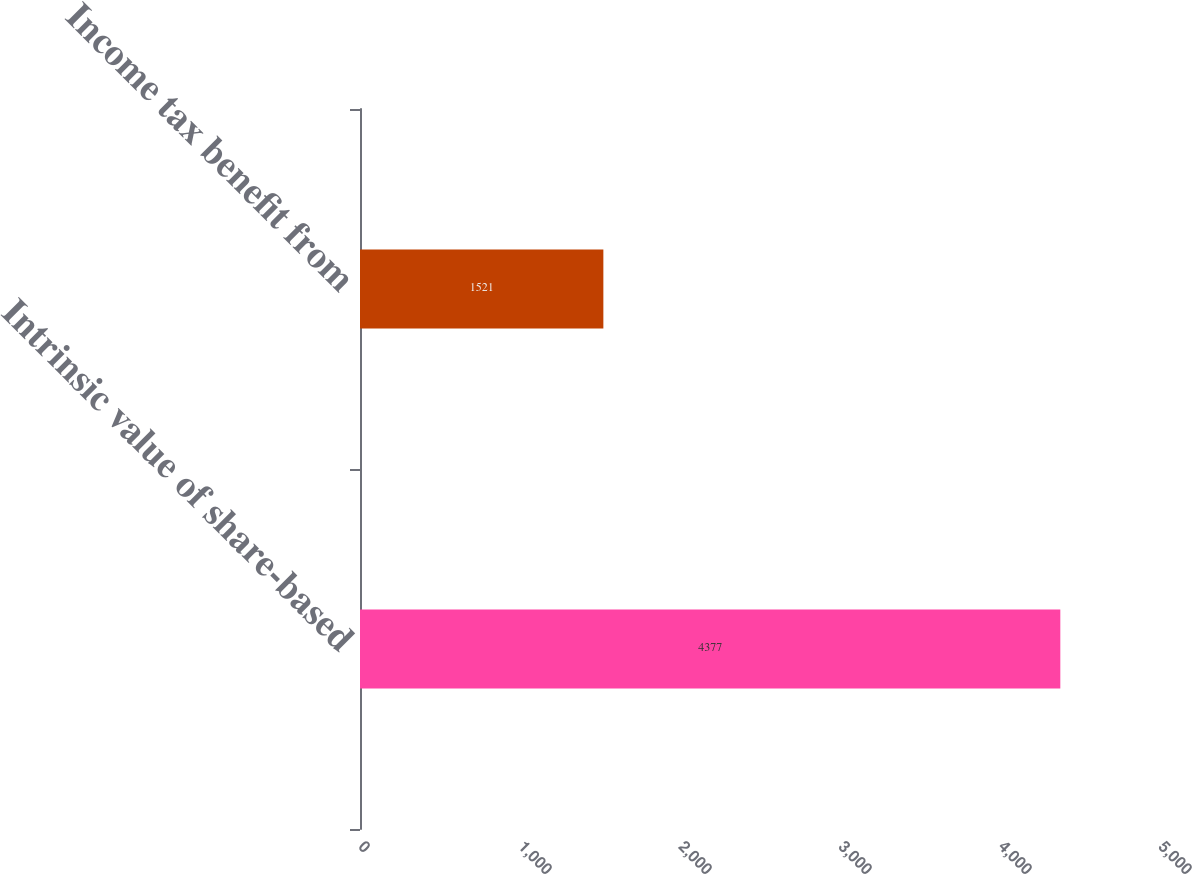<chart> <loc_0><loc_0><loc_500><loc_500><bar_chart><fcel>Intrinsic value of share-based<fcel>Income tax benefit from<nl><fcel>4377<fcel>1521<nl></chart> 